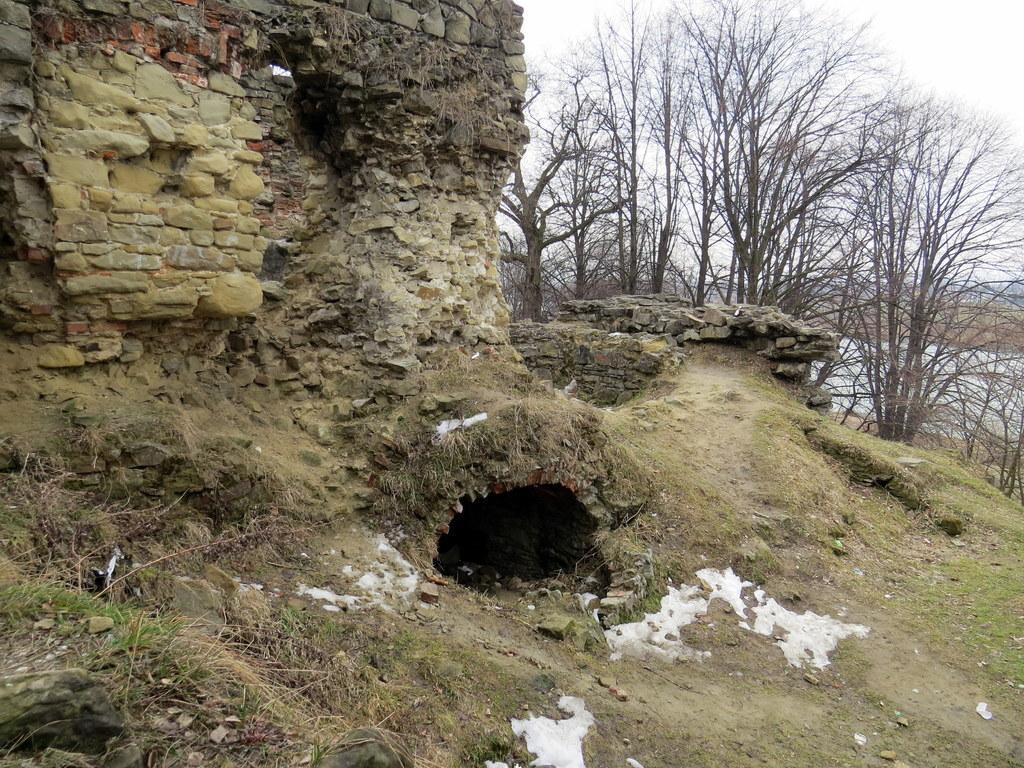How would you summarize this image in a sentence or two? In the foreground we can see grass, stones and soil. In the middle of the picture we can see a stone construction. In the background there are trees and sky. 